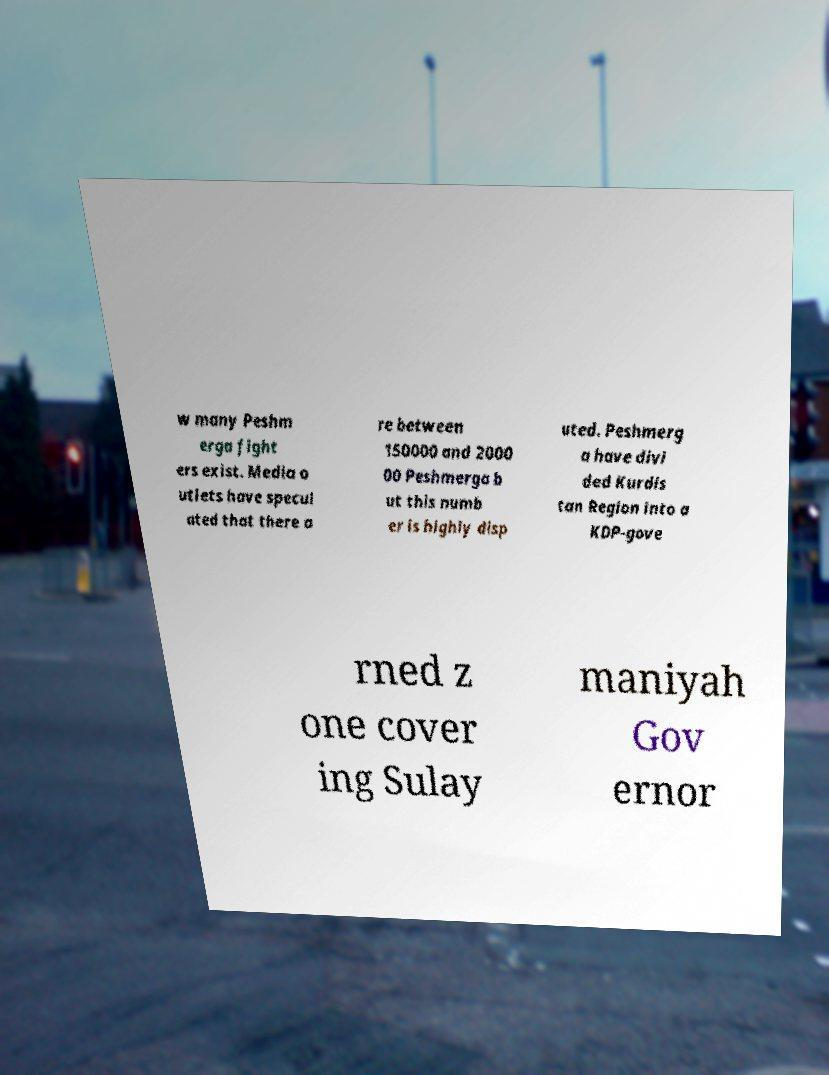For documentation purposes, I need the text within this image transcribed. Could you provide that? w many Peshm erga fight ers exist. Media o utlets have specul ated that there a re between 150000 and 2000 00 Peshmerga b ut this numb er is highly disp uted. Peshmerg a have divi ded Kurdis tan Region into a KDP-gove rned z one cover ing Sulay maniyah Gov ernor 